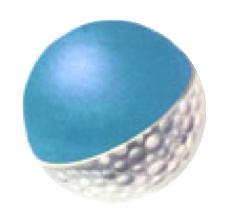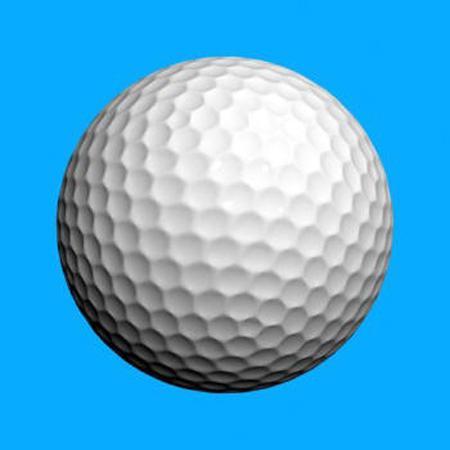The first image is the image on the left, the second image is the image on the right. Assess this claim about the two images: "One of the balls is two different colors.". Correct or not? Answer yes or no. Yes. The first image is the image on the left, the second image is the image on the right. Assess this claim about the two images: "An image shows a golf ball bisected vertically, with its blue interior showing on the right side of the ball.". Correct or not? Answer yes or no. No. 